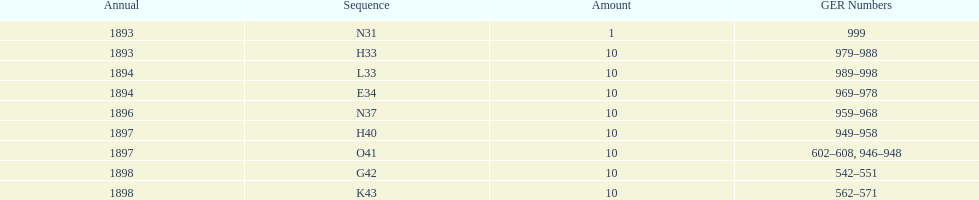What is the last year listed? 1898. 